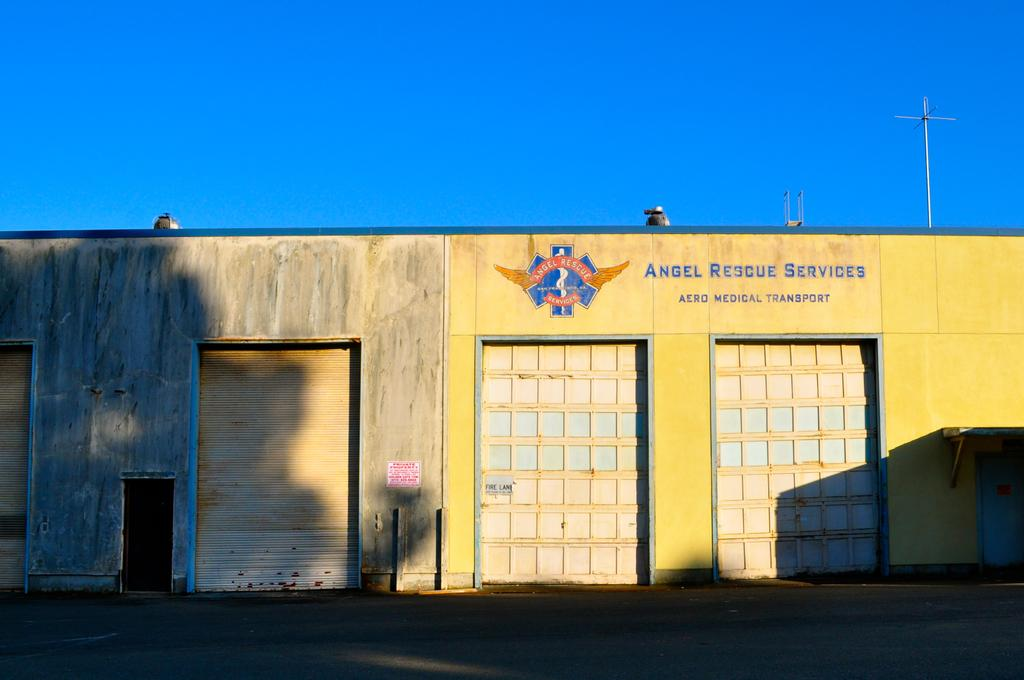What is written or displayed on the house in the image? There is text on the house in the image. What type of window covering is visible on the house? There are shutters visible in the image. What can be seen in the background of the image? There are poles in the background of the image. How does the fan contribute to the discovery of new species in the image? There is no fan present in the image, and therefore no fan-related discovery can be observed. 